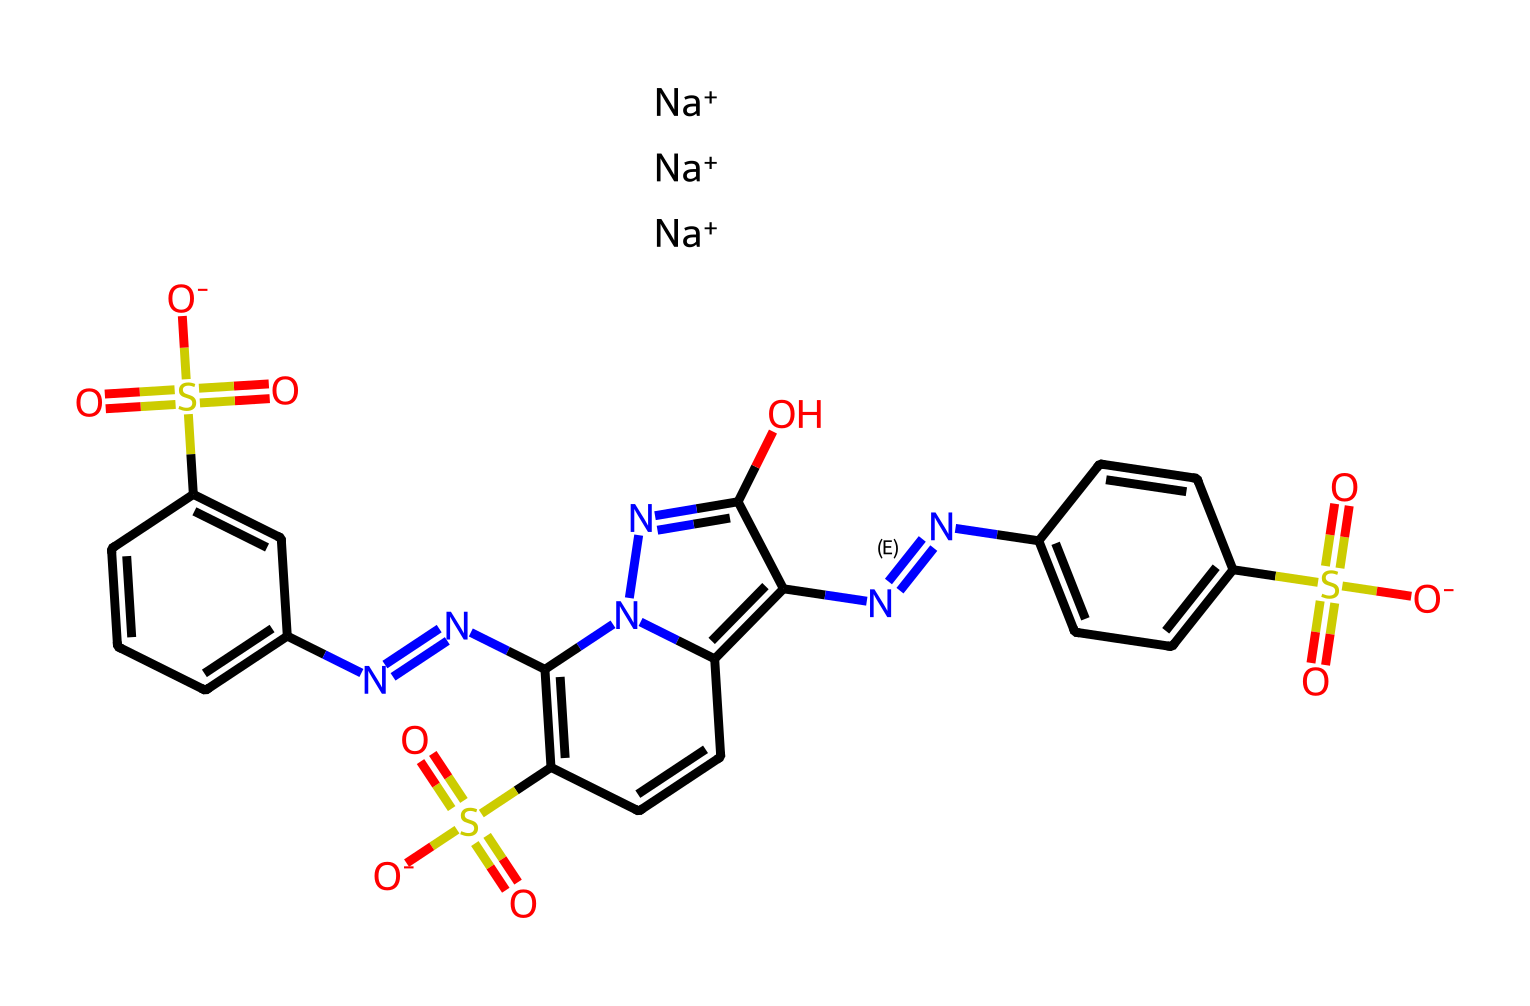What is the molecular formula of tartrazine? By analyzing the SMILES representation, we can identify the elements present and count their atoms. The structure indicates the presence of carbon (C), hydrogen (H), sulfur (S), nitrogen (N), and oxygen (O) atoms. After counting, the molecular formula for tartrazine is determined: C16H9N3Na2O7S2.
Answer: C16H9N3Na2O7S2 How many nitrogen atoms are in tartrazine? From the SMILES representation, we can identify the number of nitrogen atoms directly. The presence of "N" in the structure indicates nitrogen, and counting them gives us three nitrogen atoms in total.
Answer: 3 What type of food additive is tartrazine? Tartrazine is identified as a synthetic food coloring agent, particularly known for being a dye. The chemical structure corresponds to a class of compounds used primarily for coloring purposes in food.
Answer: synthetic dye What functional groups are present in tartrazine? Examining the SMILES reveals various functional groups, including sulfonate (-SO3), azo (-N=N-), and hydroxyl (-OH) groups. These groups contribute to the chemical's properties.
Answer: sulfonate, azo, hydroxyl How many oxygen atoms does tartrazine contain? By assessing the SMILES notation, we can locate the oxygen atoms represented. Counting the "O" characters in the structure shows that there are seven oxygen atoms connected to different parts of the molecule.
Answer: 7 What is the primary use of tartrazine in food products? Tartrazine is mainly utilized as a coloring agent in many food items, giving a yellow hue to products. Its purpose is commonly associated with enhancing the visual appeal of food.
Answer: coloring agent What charge does tartrazine exhibit in solution? The SMILES representation indicates that tartrazine has sodium ions (Na+) associated with it, suggesting a negatively charged structure overall in solution due to its sulfonate groups.
Answer: negative charge 